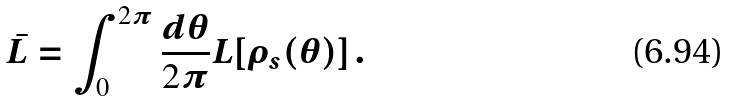<formula> <loc_0><loc_0><loc_500><loc_500>\bar { L } = \int _ { 0 } ^ { 2 \pi } \frac { d \theta } { 2 \pi } L [ \rho _ { s } ( \theta ) ] \, .</formula> 